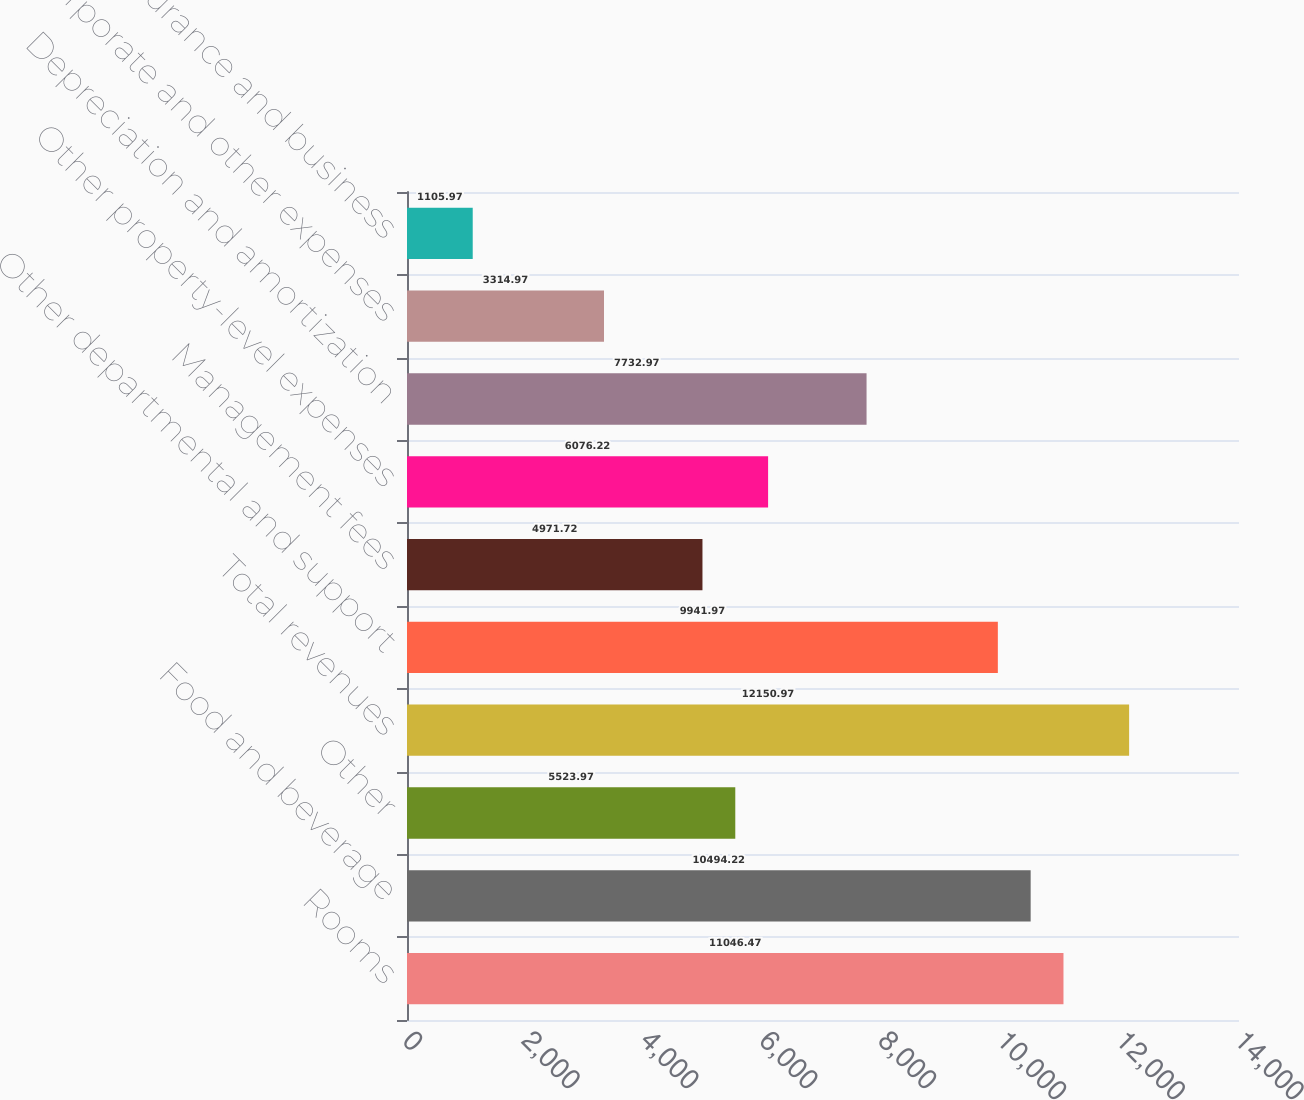Convert chart. <chart><loc_0><loc_0><loc_500><loc_500><bar_chart><fcel>Rooms<fcel>Food and beverage<fcel>Other<fcel>Total revenues<fcel>Other departmental and support<fcel>Management fees<fcel>Other property-level expenses<fcel>Depreciation and amortization<fcel>Corporate and other expenses<fcel>Gain on insurance and business<nl><fcel>11046.5<fcel>10494.2<fcel>5523.97<fcel>12151<fcel>9941.97<fcel>4971.72<fcel>6076.22<fcel>7732.97<fcel>3314.97<fcel>1105.97<nl></chart> 